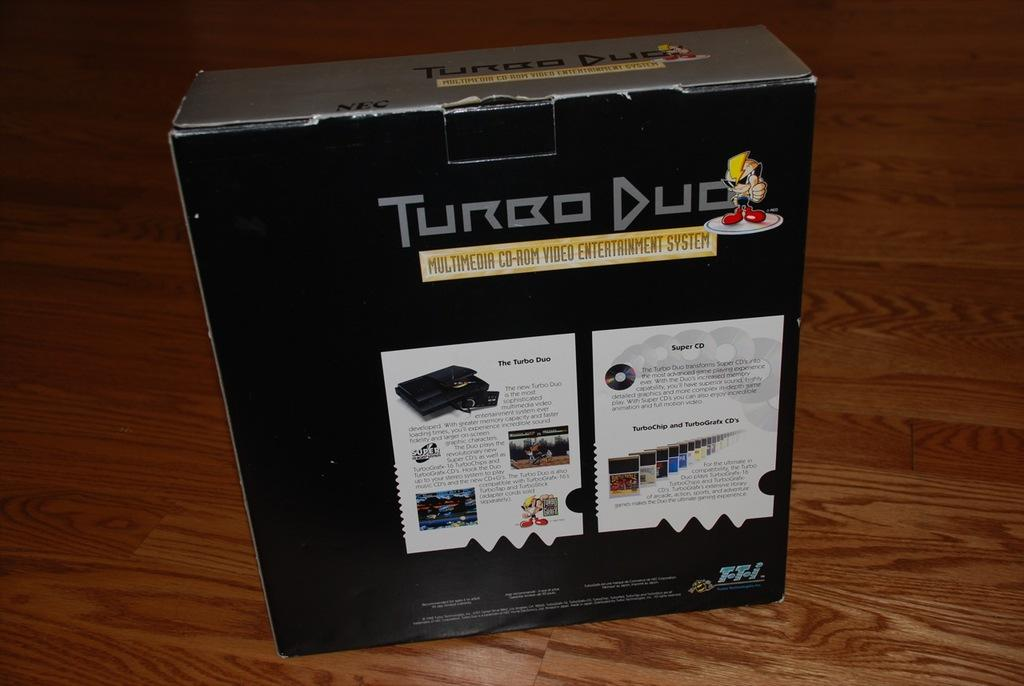Provide a one-sentence caption for the provided image. A box contains Turbo Duo, a multimedia CD-Rom video entertainment system. 